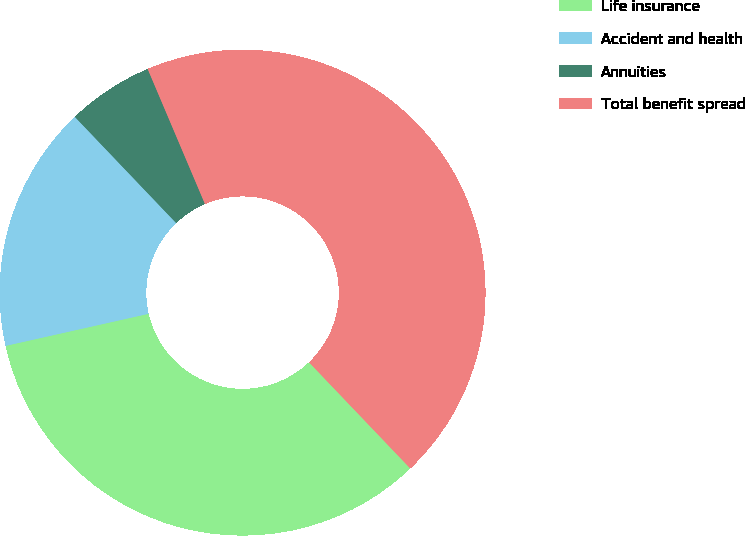Convert chart. <chart><loc_0><loc_0><loc_500><loc_500><pie_chart><fcel>Life insurance<fcel>Accident and health<fcel>Annuities<fcel>Total benefit spread<nl><fcel>33.61%<fcel>16.39%<fcel>5.74%<fcel>44.26%<nl></chart> 